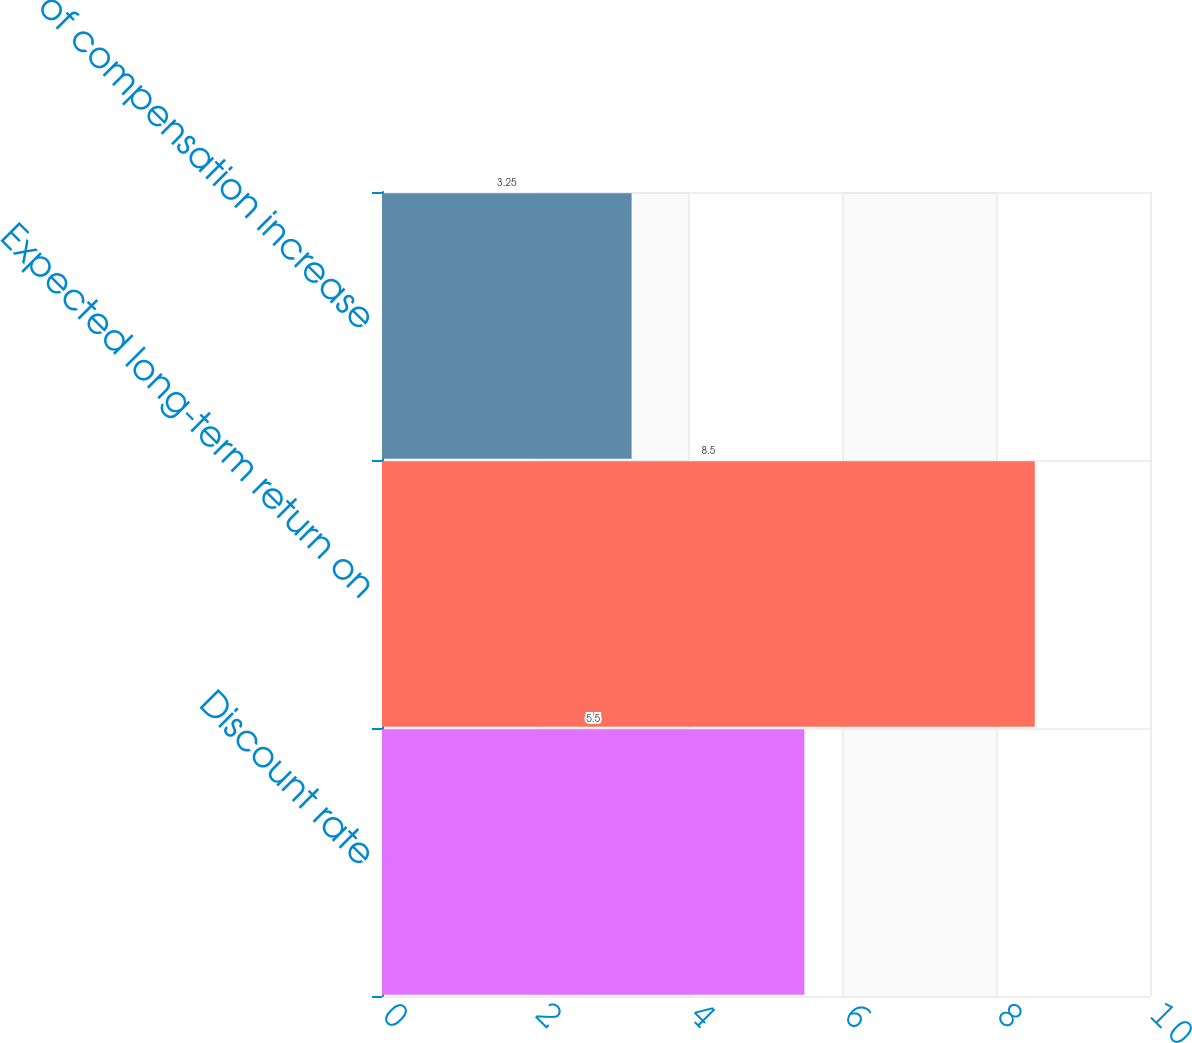Convert chart. <chart><loc_0><loc_0><loc_500><loc_500><bar_chart><fcel>Discount rate<fcel>Expected long-term return on<fcel>Rate of compensation increase<nl><fcel>5.5<fcel>8.5<fcel>3.25<nl></chart> 